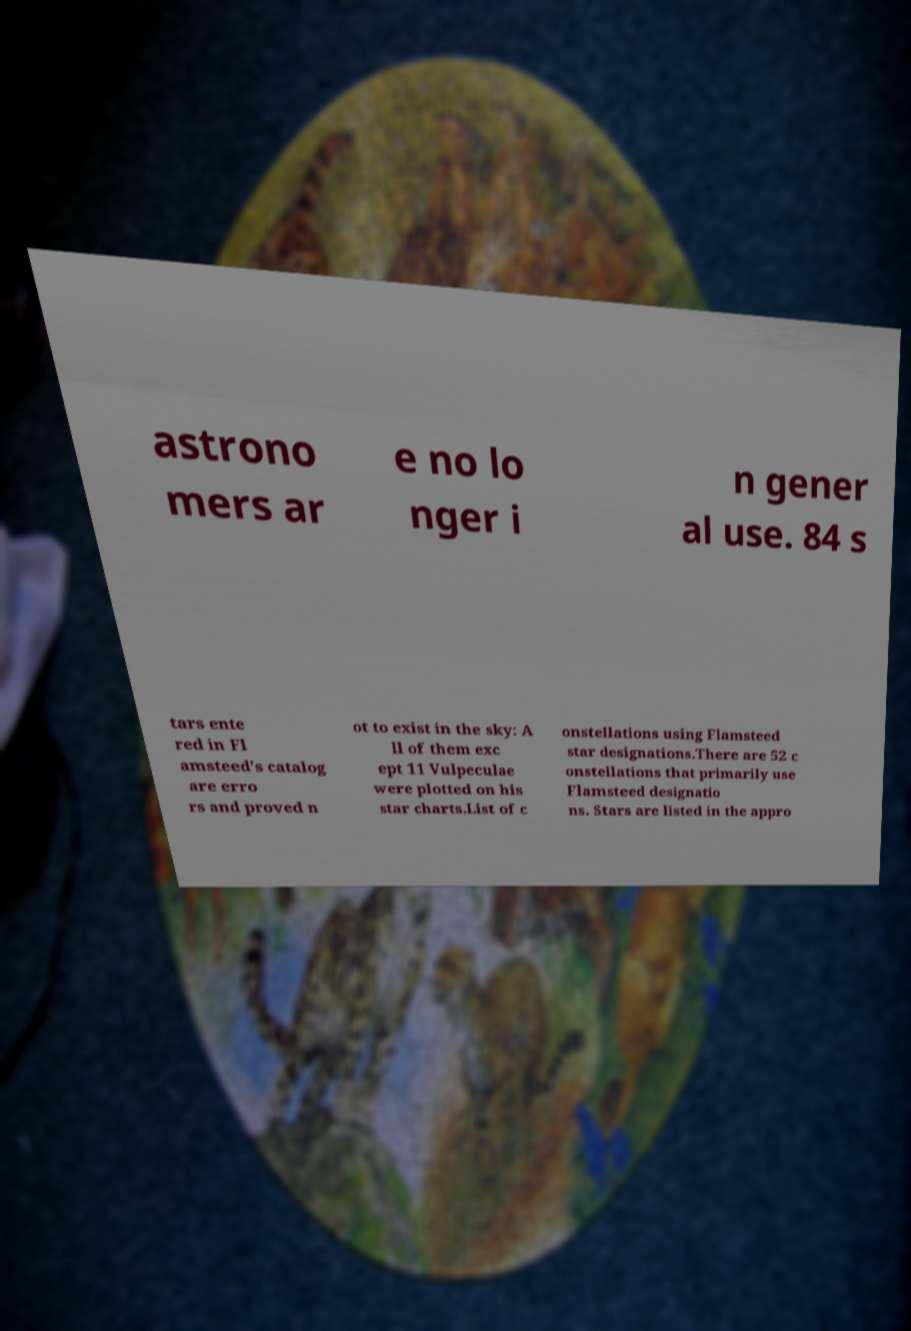Please read and relay the text visible in this image. What does it say? astrono mers ar e no lo nger i n gener al use. 84 s tars ente red in Fl amsteed's catalog are erro rs and proved n ot to exist in the sky: A ll of them exc ept 11 Vulpeculae were plotted on his star charts.List of c onstellations using Flamsteed star designations.There are 52 c onstellations that primarily use Flamsteed designatio ns. Stars are listed in the appro 